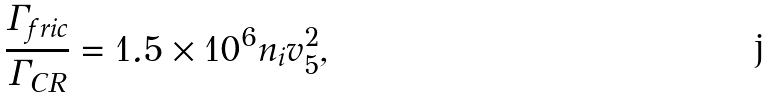<formula> <loc_0><loc_0><loc_500><loc_500>\frac { \Gamma _ { f r i c } } { \Gamma _ { C R } } = 1 . 5 \times 1 0 ^ { 6 } n _ { i } v _ { 5 } ^ { 2 } ,</formula> 